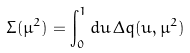<formula> <loc_0><loc_0><loc_500><loc_500>\Sigma ( \mu ^ { 2 } ) = \int _ { 0 } ^ { 1 } d u \, \Delta q ( u , \mu ^ { 2 } )</formula> 